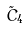<formula> <loc_0><loc_0><loc_500><loc_500>\tilde { C } _ { 4 }</formula> 